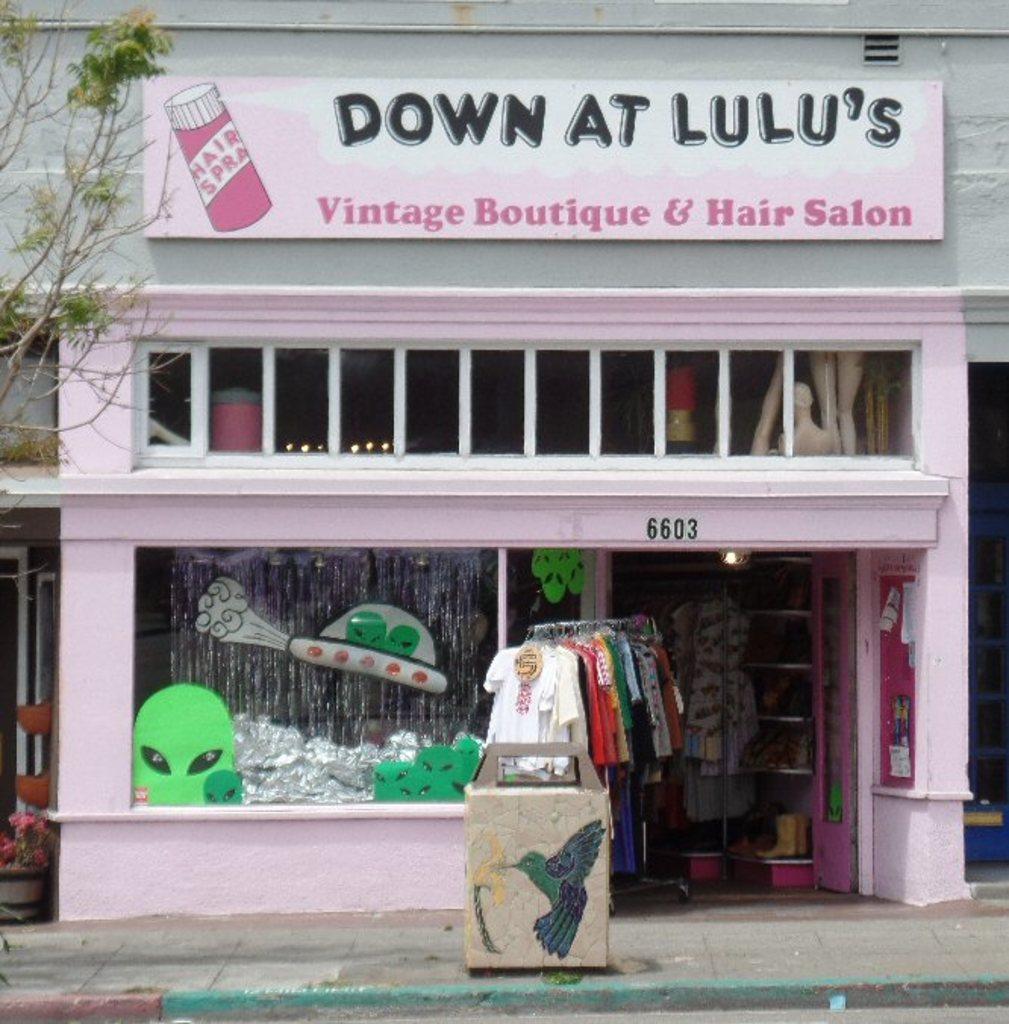Can you describe this image briefly? In this image in the center there are clothes hanging and there is a building with some text written on the top of the building. On the left side there is a tree and there are flowers. 